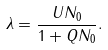Convert formula to latex. <formula><loc_0><loc_0><loc_500><loc_500>\lambda = \frac { U N _ { 0 } } { 1 + Q N _ { 0 } } .</formula> 